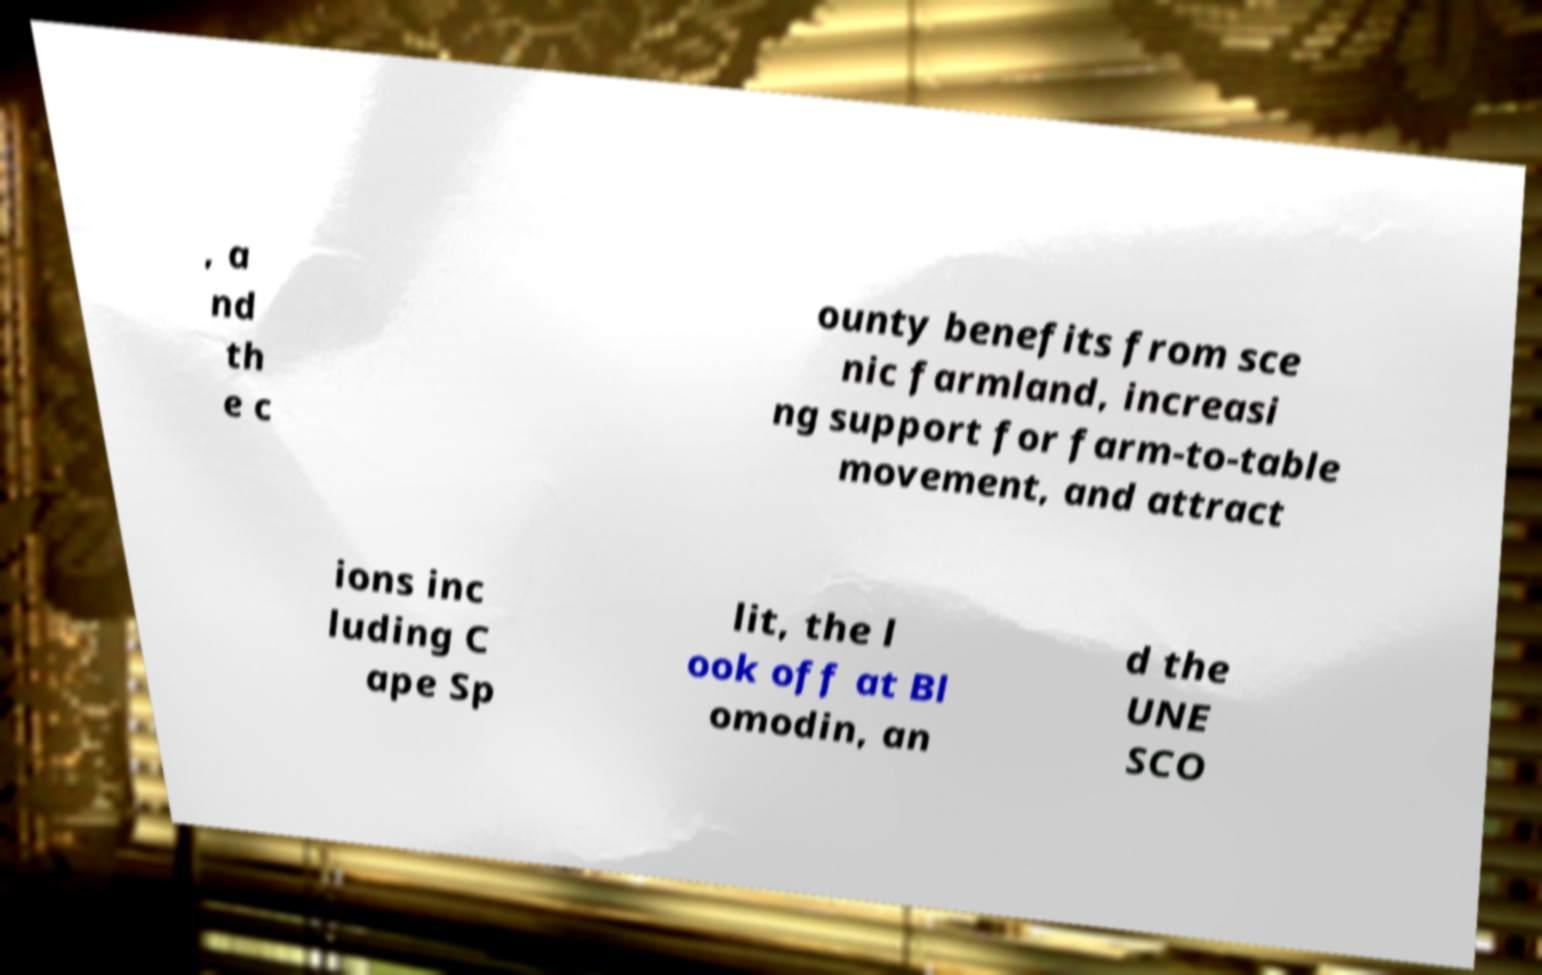Can you accurately transcribe the text from the provided image for me? , a nd th e c ounty benefits from sce nic farmland, increasi ng support for farm-to-table movement, and attract ions inc luding C ape Sp lit, the l ook off at Bl omodin, an d the UNE SCO 